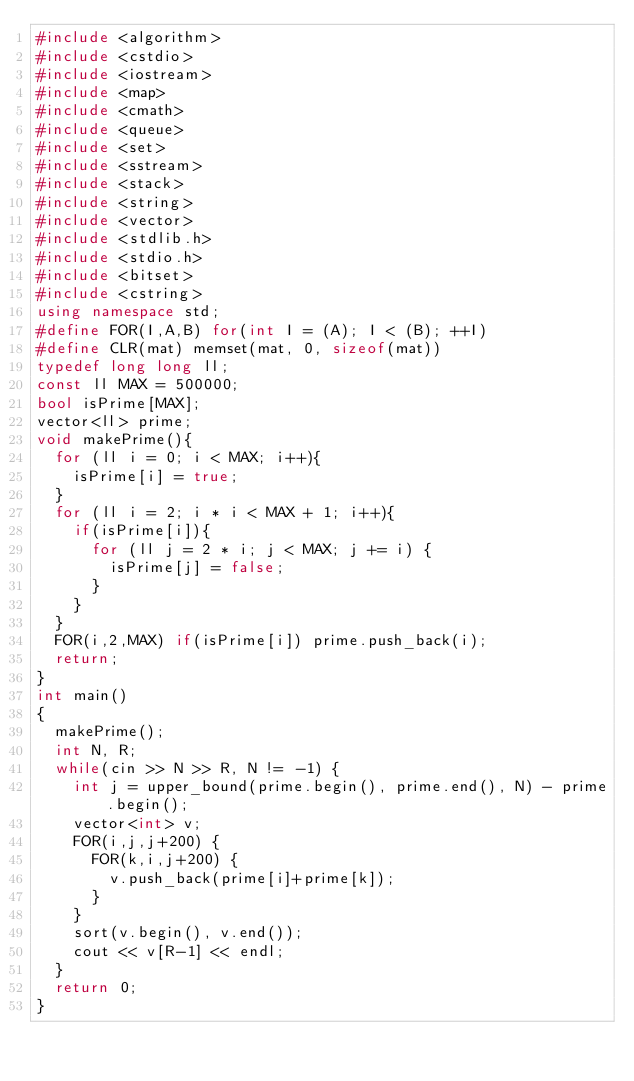Convert code to text. <code><loc_0><loc_0><loc_500><loc_500><_C++_>#include <algorithm>
#include <cstdio>
#include <iostream>
#include <map>
#include <cmath>
#include <queue>
#include <set>
#include <sstream>
#include <stack>
#include <string>
#include <vector>
#include <stdlib.h>
#include <stdio.h>
#include <bitset>
#include <cstring>
using namespace std;
#define FOR(I,A,B) for(int I = (A); I < (B); ++I)
#define CLR(mat) memset(mat, 0, sizeof(mat))
typedef long long ll;
const ll MAX = 500000;
bool isPrime[MAX];
vector<ll> prime;
void makePrime(){
  for (ll i = 0; i < MAX; i++){
    isPrime[i] = true;
  }
  for (ll i = 2; i * i < MAX + 1; i++){
    if(isPrime[i]){
      for (ll j = 2 * i; j < MAX; j += i) {
        isPrime[j] = false;
      }
    }
  }
  FOR(i,2,MAX) if(isPrime[i]) prime.push_back(i);
  return;
}
int main()
{
  makePrime();
  int N, R;
  while(cin >> N >> R, N != -1) {
    int j = upper_bound(prime.begin(), prime.end(), N) - prime.begin();
    vector<int> v;
    FOR(i,j,j+200) {
      FOR(k,i,j+200) {
        v.push_back(prime[i]+prime[k]);
      }
    }
    sort(v.begin(), v.end());
    cout << v[R-1] << endl;
  }
  return 0;
}</code> 